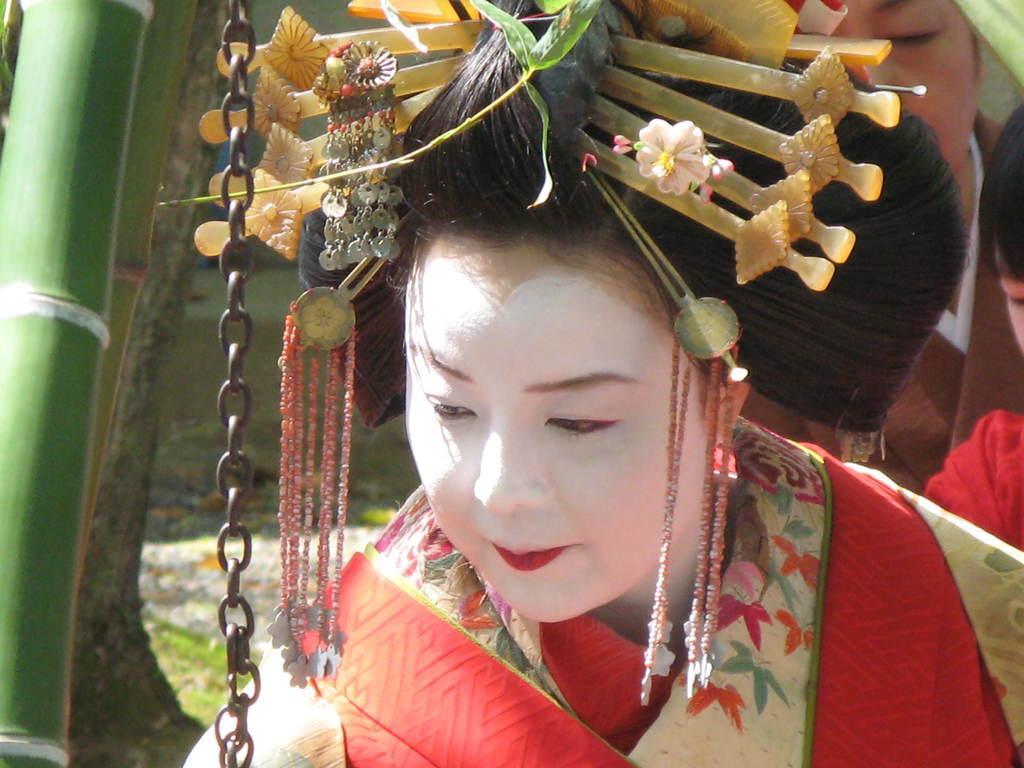Can you describe this image briefly? In the foreground I can see a woman is wearing a crown on head. In the left I can see a bamboo tree and a chain. In the background I can see a person. This image is taken during a day. 